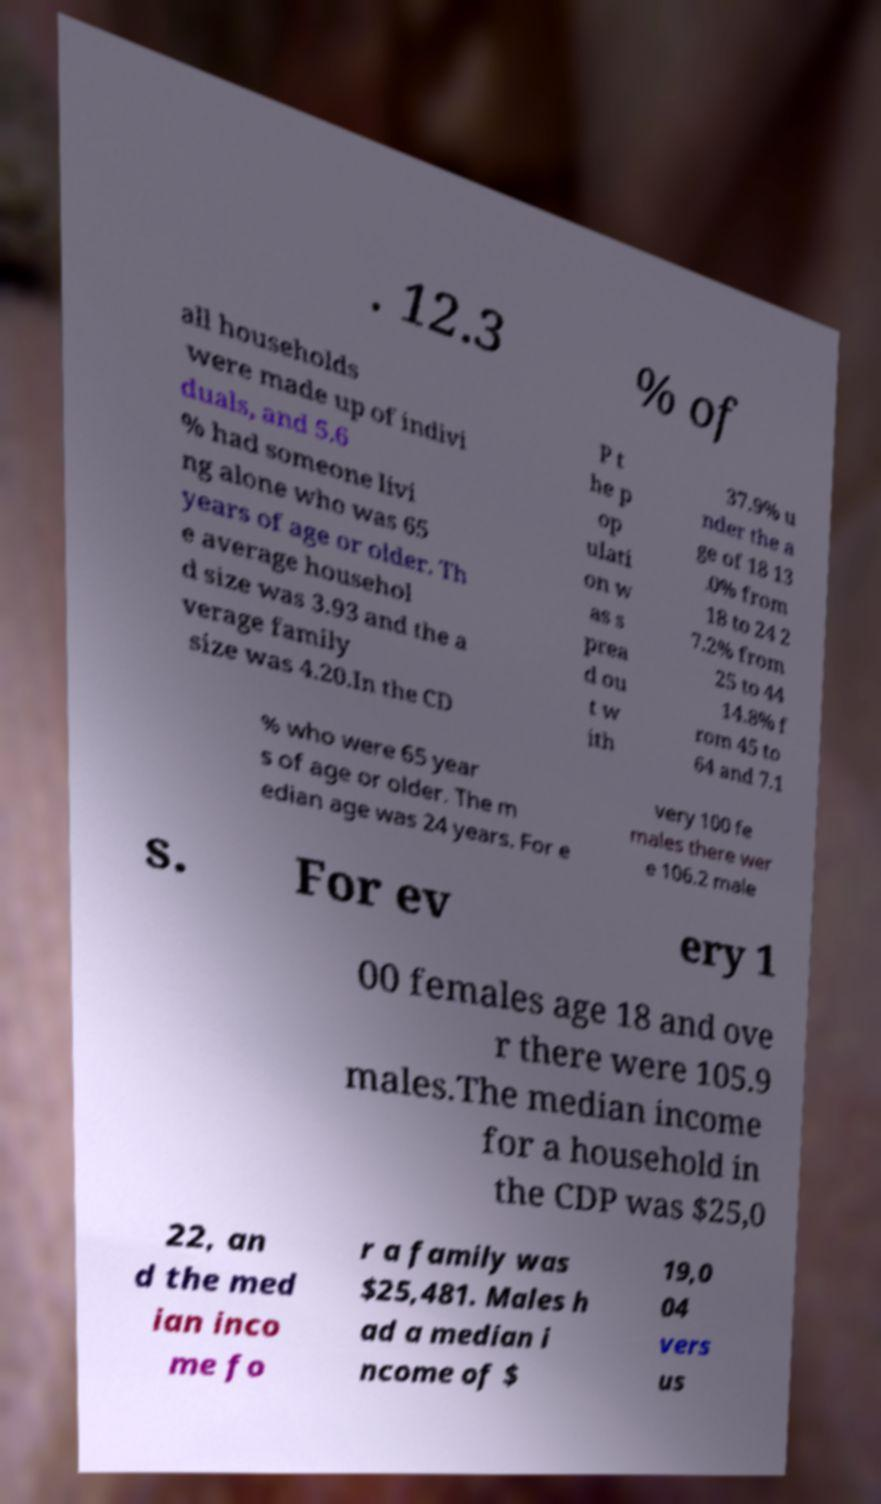For documentation purposes, I need the text within this image transcribed. Could you provide that? . 12.3 % of all households were made up of indivi duals, and 5.6 % had someone livi ng alone who was 65 years of age or older. Th e average househol d size was 3.93 and the a verage family size was 4.20.In the CD P t he p op ulati on w as s prea d ou t w ith 37.9% u nder the a ge of 18 13 .0% from 18 to 24 2 7.2% from 25 to 44 14.8% f rom 45 to 64 and 7.1 % who were 65 year s of age or older. The m edian age was 24 years. For e very 100 fe males there wer e 106.2 male s. For ev ery 1 00 females age 18 and ove r there were 105.9 males.The median income for a household in the CDP was $25,0 22, an d the med ian inco me fo r a family was $25,481. Males h ad a median i ncome of $ 19,0 04 vers us 